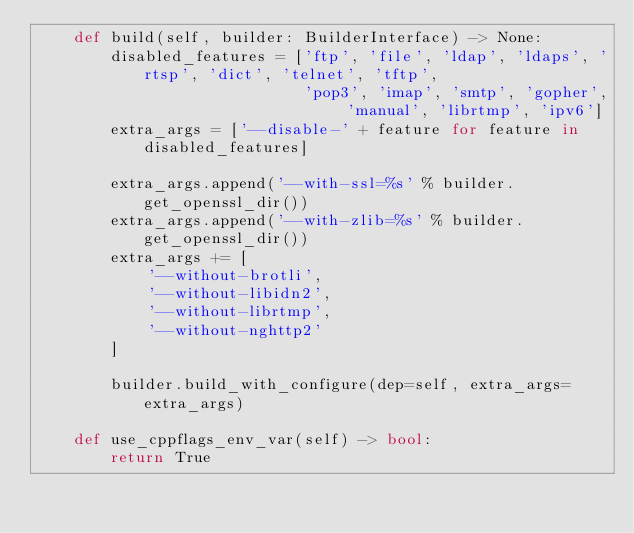<code> <loc_0><loc_0><loc_500><loc_500><_Python_>    def build(self, builder: BuilderInterface) -> None:
        disabled_features = ['ftp', 'file', 'ldap', 'ldaps', 'rtsp', 'dict', 'telnet', 'tftp',
                             'pop3', 'imap', 'smtp', 'gopher', 'manual', 'librtmp', 'ipv6']
        extra_args = ['--disable-' + feature for feature in disabled_features]

        extra_args.append('--with-ssl=%s' % builder.get_openssl_dir())
        extra_args.append('--with-zlib=%s' % builder.get_openssl_dir())
        extra_args += [
            '--without-brotli',
            '--without-libidn2',
            '--without-librtmp',
            '--without-nghttp2'
        ]

        builder.build_with_configure(dep=self, extra_args=extra_args)

    def use_cppflags_env_var(self) -> bool:
        return True
</code> 